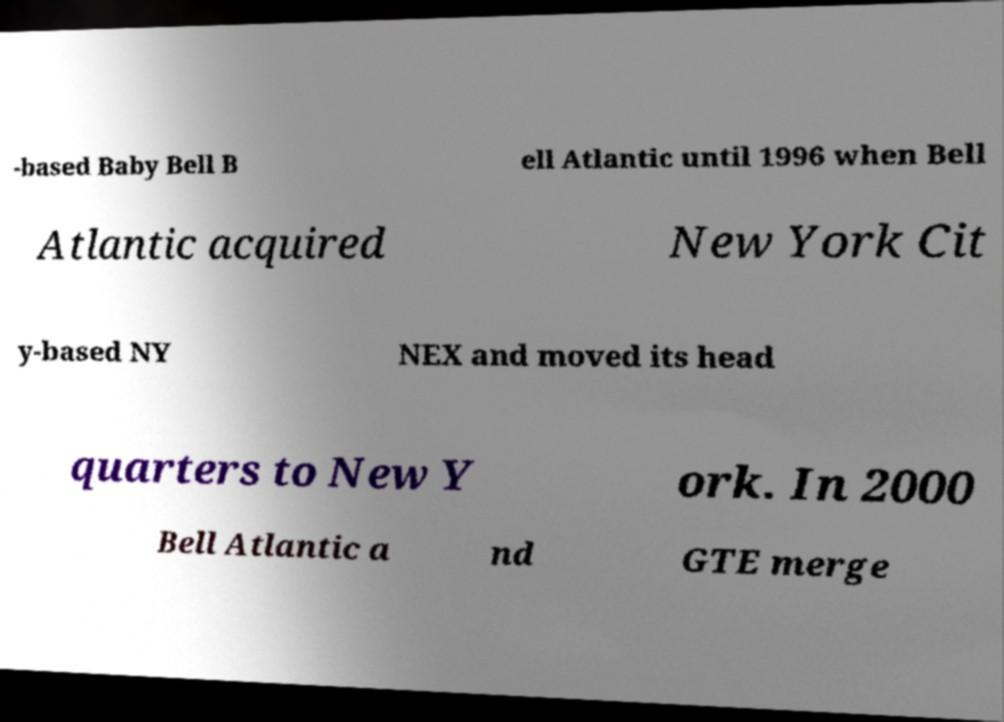Can you read and provide the text displayed in the image?This photo seems to have some interesting text. Can you extract and type it out for me? -based Baby Bell B ell Atlantic until 1996 when Bell Atlantic acquired New York Cit y-based NY NEX and moved its head quarters to New Y ork. In 2000 Bell Atlantic a nd GTE merge 